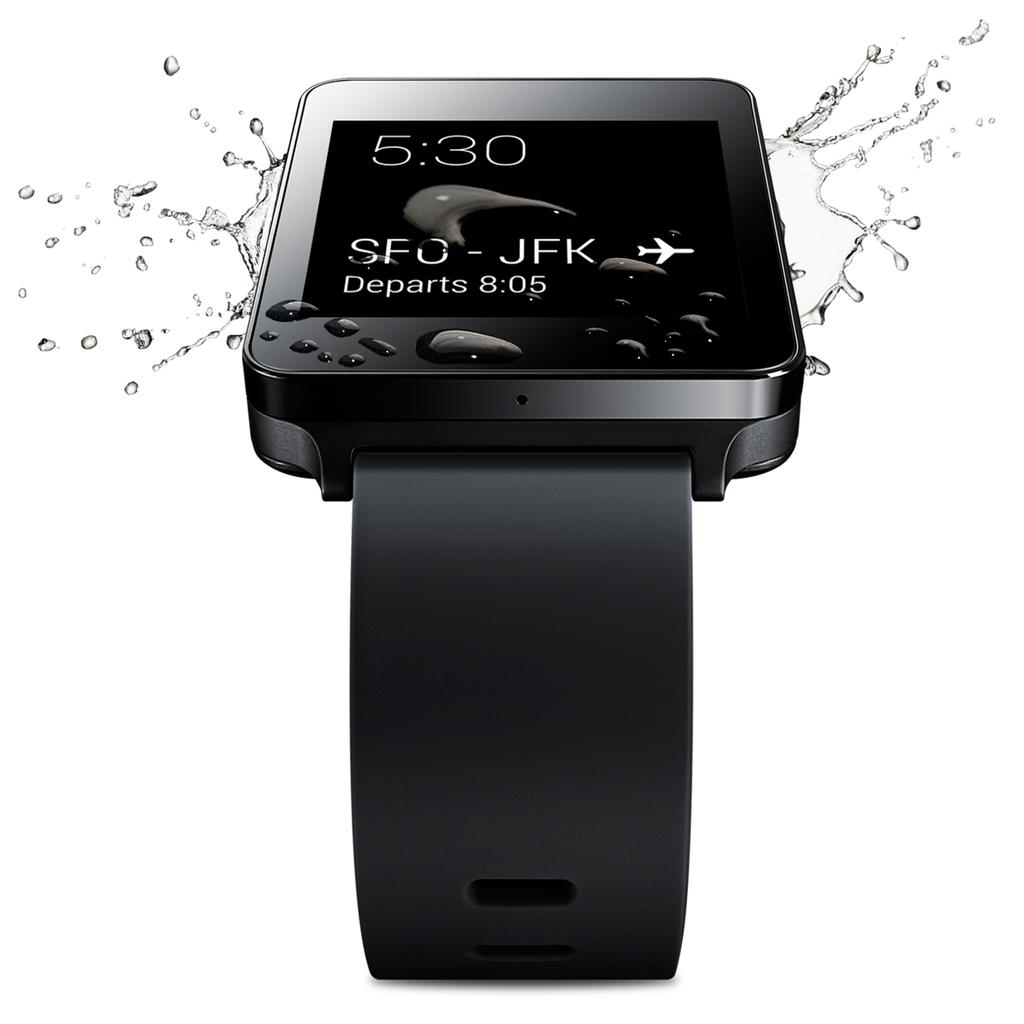<image>
Present a compact description of the photo's key features. The ad shows a watch showing a flight from SFO to JFK departing at 8:05. 